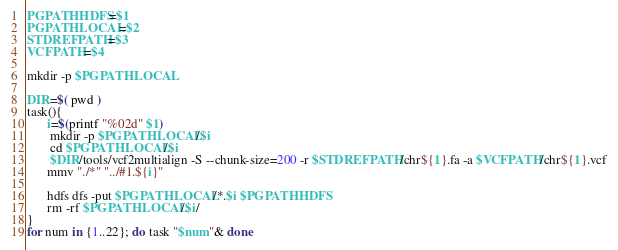Convert code to text. <code><loc_0><loc_0><loc_500><loc_500><_Bash_>
PGPATHHDFS=$1
PGPATHLOCAL=$2
STDREFPATH=$3
VCFPATH=$4

mkdir -p $PGPATHLOCAL

DIR=$( pwd )
task(){ 
      i=$(printf "%02d" $1)
       mkdir -p $PGPATHLOCAL/$i
       cd $PGPATHLOCAL/$i
       $DIR/tools/vcf2multialign -S --chunk-size=200 -r $STDREFPATH/chr${1}.fa -a $VCFPATH/chr${1}.vcf
      mmv "./*" "../#1.${i}"

      hdfs dfs -put $PGPATHLOCAL/*.$i $PGPATHHDFS
      rm -rf $PGPATHLOCAL/$i/
}
for num in {1..22}; do task "$num"& done

</code> 